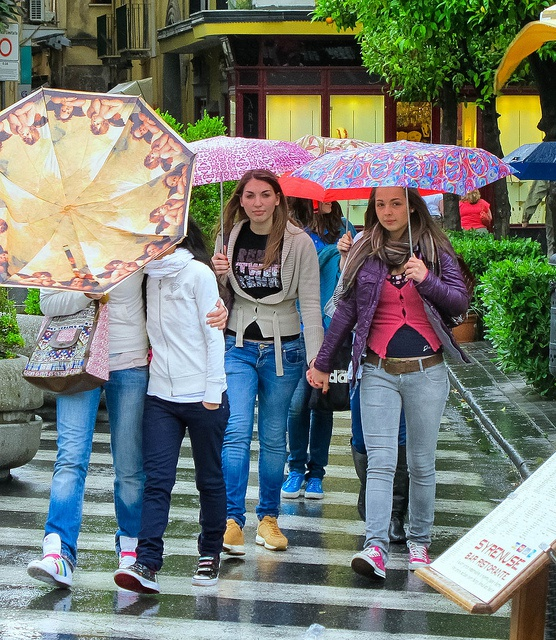Describe the objects in this image and their specific colors. I can see people in black, gray, and darkgray tones, umbrella in black, tan, beige, and darkgray tones, people in black, darkgray, blue, and navy tones, people in black, darkgray, lightgray, blue, and lightblue tones, and people in black, lightblue, and navy tones in this image. 